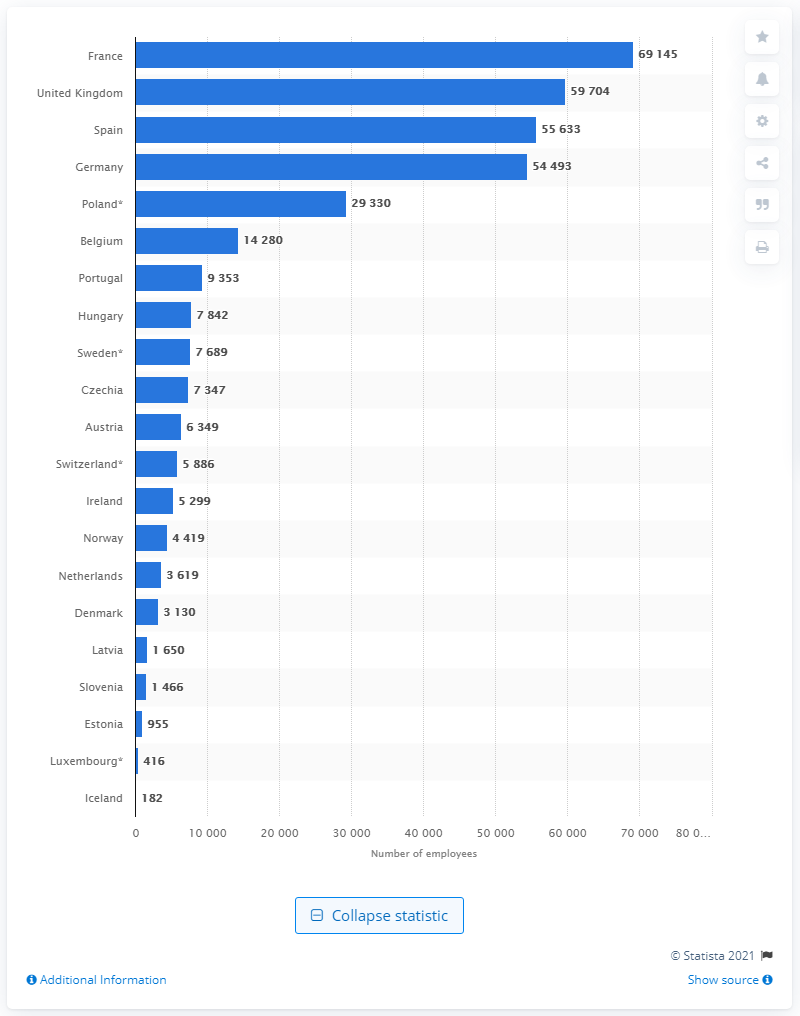List a handful of essential elements in this visual. In 2018, there were 69,145 pharmacists employed in France. In 2018, over 69 thousand pharmacists were employed in the healthcare sector in France. 